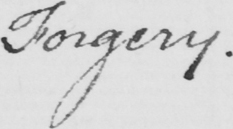What is written in this line of handwriting? Forgery . 